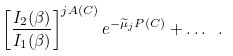<formula> <loc_0><loc_0><loc_500><loc_500>\left [ \frac { I _ { 2 } ( \beta ) } { I _ { 1 } ( \beta ) } \right ] ^ { j A ( C ) } e ^ { - \widetilde { \mu } _ { j } P ( C ) } + \dots \ .</formula> 